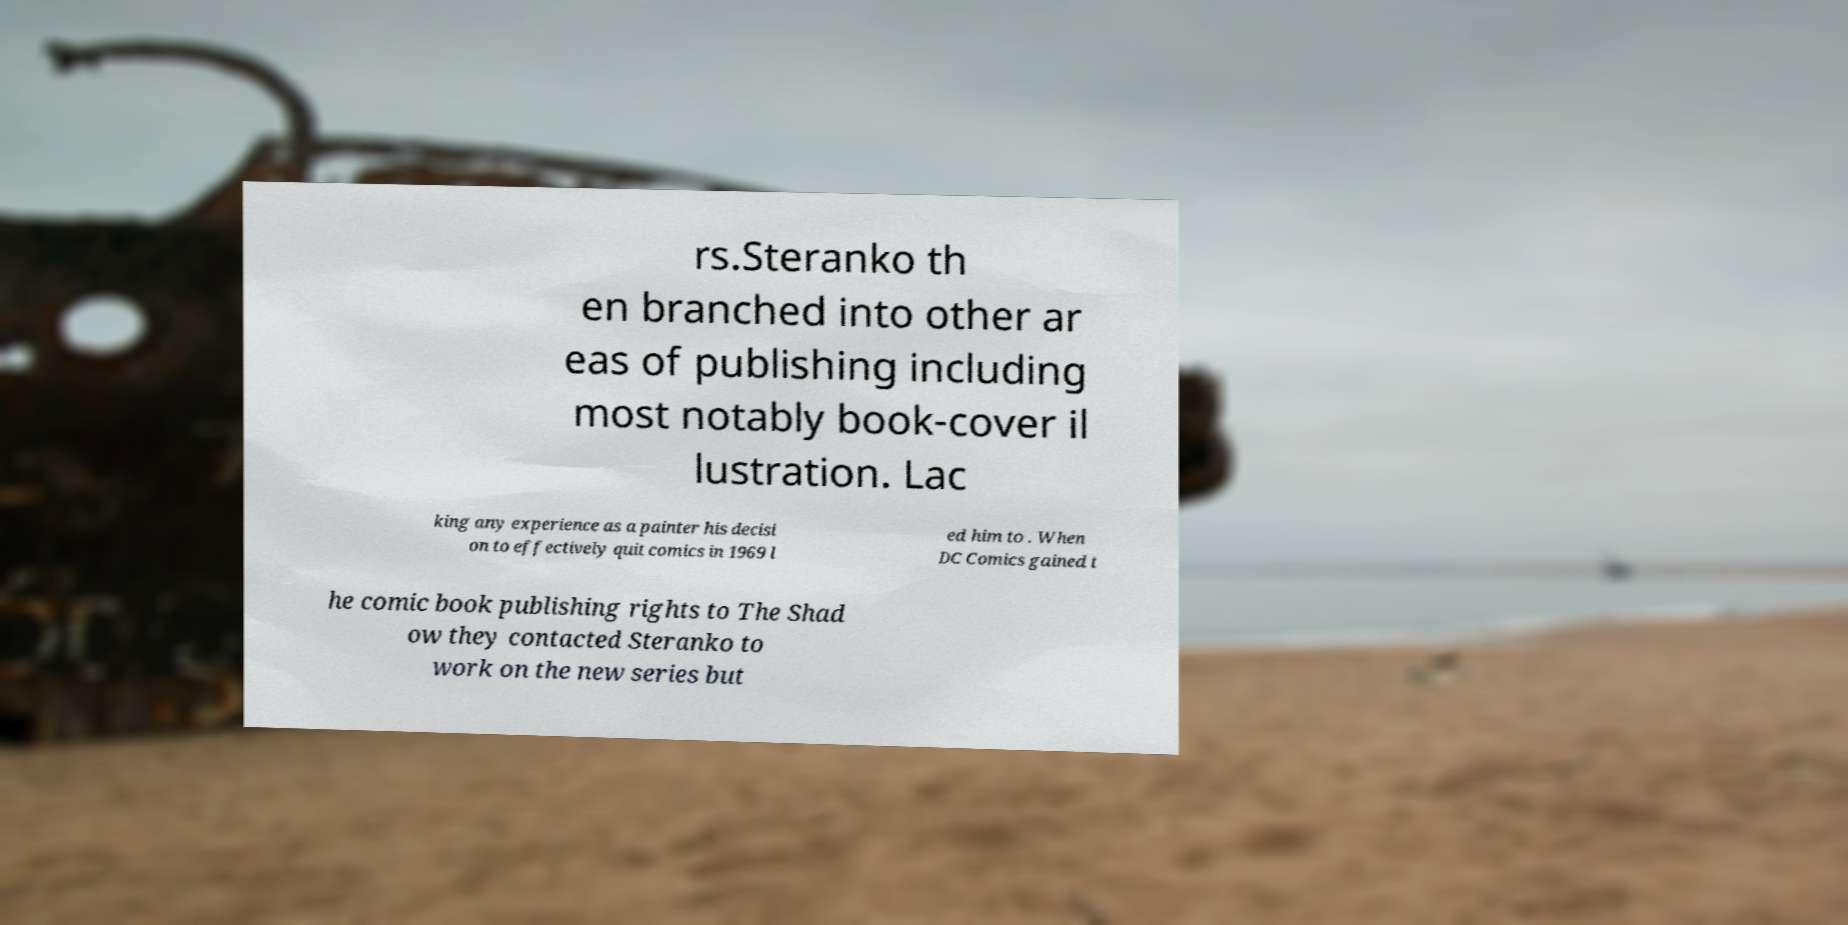For documentation purposes, I need the text within this image transcribed. Could you provide that? rs.Steranko th en branched into other ar eas of publishing including most notably book-cover il lustration. Lac king any experience as a painter his decisi on to effectively quit comics in 1969 l ed him to . When DC Comics gained t he comic book publishing rights to The Shad ow they contacted Steranko to work on the new series but 